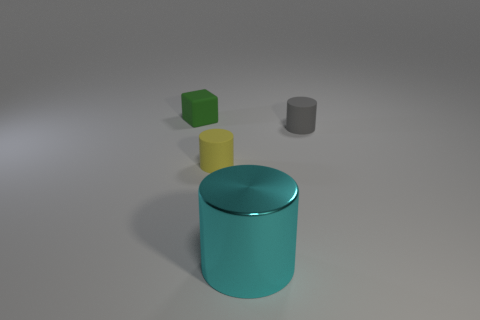Is the number of yellow objects that are behind the big cylinder greater than the number of tiny blocks?
Ensure brevity in your answer.  No. There is a tiny green thing that is the same material as the small gray thing; what shape is it?
Keep it short and to the point. Cube. There is a rubber cylinder in front of the gray matte object; does it have the same size as the gray cylinder?
Offer a terse response. Yes. What is the shape of the small object that is in front of the small rubber cylinder right of the small yellow object?
Offer a very short reply. Cylinder. How big is the matte cylinder in front of the cylinder that is right of the big cyan metal thing?
Keep it short and to the point. Small. What color is the tiny rubber thing in front of the tiny gray cylinder?
Ensure brevity in your answer.  Yellow. There is a yellow object that is made of the same material as the green cube; what size is it?
Your answer should be compact. Small. What number of other rubber objects have the same shape as the small gray matte thing?
Give a very brief answer. 1. What is the material of the block that is the same size as the yellow cylinder?
Offer a very short reply. Rubber. Are there any cylinders made of the same material as the tiny green object?
Offer a very short reply. Yes. 